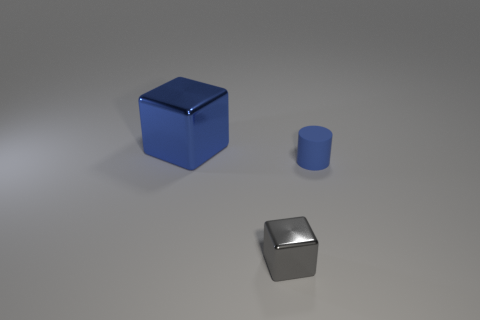What is the color of the metallic cube that is on the right side of the large blue thing? gray 